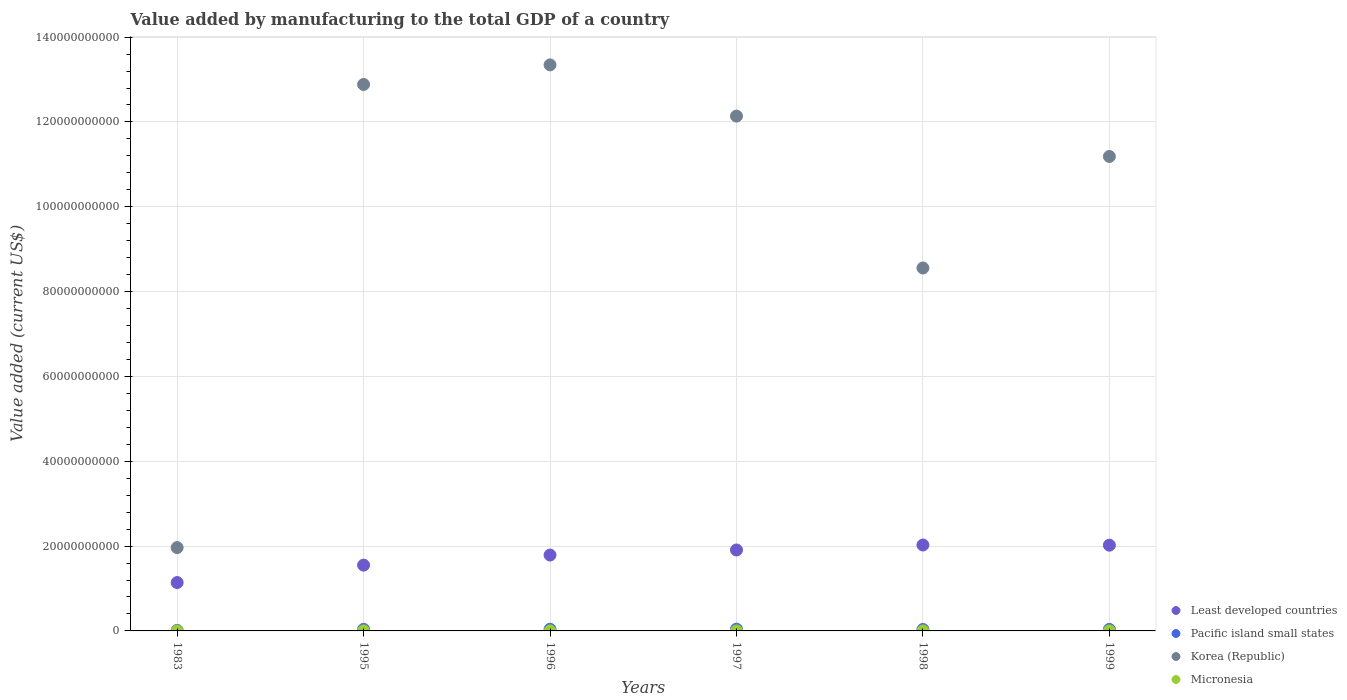How many different coloured dotlines are there?
Offer a terse response. 4. What is the value added by manufacturing to the total GDP in Least developed countries in 1996?
Give a very brief answer. 1.79e+1. Across all years, what is the maximum value added by manufacturing to the total GDP in Pacific island small states?
Your answer should be compact. 4.08e+08. Across all years, what is the minimum value added by manufacturing to the total GDP in Pacific island small states?
Offer a terse response. 1.26e+08. In which year was the value added by manufacturing to the total GDP in Pacific island small states minimum?
Keep it short and to the point. 1983. What is the total value added by manufacturing to the total GDP in Korea (Republic) in the graph?
Make the answer very short. 6.01e+11. What is the difference between the value added by manufacturing to the total GDP in Pacific island small states in 1983 and that in 1996?
Your answer should be very brief. -2.58e+08. What is the difference between the value added by manufacturing to the total GDP in Least developed countries in 1983 and the value added by manufacturing to the total GDP in Korea (Republic) in 1999?
Offer a terse response. -1.00e+11. What is the average value added by manufacturing to the total GDP in Korea (Republic) per year?
Offer a very short reply. 1.00e+11. In the year 1998, what is the difference between the value added by manufacturing to the total GDP in Micronesia and value added by manufacturing to the total GDP in Least developed countries?
Offer a very short reply. -2.03e+1. What is the ratio of the value added by manufacturing to the total GDP in Pacific island small states in 1996 to that in 1999?
Your response must be concise. 1.08. Is the value added by manufacturing to the total GDP in Korea (Republic) in 1996 less than that in 1999?
Make the answer very short. No. What is the difference between the highest and the second highest value added by manufacturing to the total GDP in Pacific island small states?
Your response must be concise. 2.43e+07. What is the difference between the highest and the lowest value added by manufacturing to the total GDP in Micronesia?
Offer a very short reply. 3.03e+06. In how many years, is the value added by manufacturing to the total GDP in Pacific island small states greater than the average value added by manufacturing to the total GDP in Pacific island small states taken over all years?
Provide a succinct answer. 5. Is the sum of the value added by manufacturing to the total GDP in Korea (Republic) in 1996 and 1998 greater than the maximum value added by manufacturing to the total GDP in Pacific island small states across all years?
Your answer should be very brief. Yes. Is it the case that in every year, the sum of the value added by manufacturing to the total GDP in Least developed countries and value added by manufacturing to the total GDP in Micronesia  is greater than the value added by manufacturing to the total GDP in Korea (Republic)?
Your response must be concise. No. How many dotlines are there?
Keep it short and to the point. 4. What is the difference between two consecutive major ticks on the Y-axis?
Your answer should be compact. 2.00e+1. Are the values on the major ticks of Y-axis written in scientific E-notation?
Your answer should be very brief. No. How many legend labels are there?
Provide a short and direct response. 4. How are the legend labels stacked?
Your answer should be compact. Vertical. What is the title of the graph?
Your answer should be compact. Value added by manufacturing to the total GDP of a country. Does "Bhutan" appear as one of the legend labels in the graph?
Offer a very short reply. No. What is the label or title of the X-axis?
Provide a short and direct response. Years. What is the label or title of the Y-axis?
Your answer should be compact. Value added (current US$). What is the Value added (current US$) of Least developed countries in 1983?
Offer a very short reply. 1.14e+1. What is the Value added (current US$) of Pacific island small states in 1983?
Offer a terse response. 1.26e+08. What is the Value added (current US$) in Korea (Republic) in 1983?
Offer a terse response. 1.96e+1. What is the Value added (current US$) of Least developed countries in 1995?
Provide a succinct answer. 1.55e+1. What is the Value added (current US$) in Pacific island small states in 1995?
Your answer should be very brief. 3.65e+08. What is the Value added (current US$) in Korea (Republic) in 1995?
Your answer should be compact. 1.29e+11. What is the Value added (current US$) of Micronesia in 1995?
Your answer should be compact. 3.14e+06. What is the Value added (current US$) in Least developed countries in 1996?
Provide a short and direct response. 1.79e+1. What is the Value added (current US$) of Pacific island small states in 1996?
Give a very brief answer. 3.83e+08. What is the Value added (current US$) of Korea (Republic) in 1996?
Your answer should be very brief. 1.33e+11. What is the Value added (current US$) in Micronesia in 1996?
Offer a terse response. 2.63e+06. What is the Value added (current US$) in Least developed countries in 1997?
Offer a terse response. 1.91e+1. What is the Value added (current US$) in Pacific island small states in 1997?
Provide a succinct answer. 4.08e+08. What is the Value added (current US$) in Korea (Republic) in 1997?
Offer a very short reply. 1.21e+11. What is the Value added (current US$) in Micronesia in 1997?
Give a very brief answer. 3.01e+06. What is the Value added (current US$) of Least developed countries in 1998?
Give a very brief answer. 2.03e+1. What is the Value added (current US$) in Pacific island small states in 1998?
Your answer should be compact. 3.37e+08. What is the Value added (current US$) of Korea (Republic) in 1998?
Offer a very short reply. 8.56e+1. What is the Value added (current US$) of Micronesia in 1998?
Keep it short and to the point. 3.43e+06. What is the Value added (current US$) in Least developed countries in 1999?
Keep it short and to the point. 2.02e+1. What is the Value added (current US$) of Pacific island small states in 1999?
Keep it short and to the point. 3.54e+08. What is the Value added (current US$) of Korea (Republic) in 1999?
Your response must be concise. 1.12e+11. What is the Value added (current US$) of Micronesia in 1999?
Provide a short and direct response. 3.29e+06. Across all years, what is the maximum Value added (current US$) in Least developed countries?
Offer a very short reply. 2.03e+1. Across all years, what is the maximum Value added (current US$) in Pacific island small states?
Make the answer very short. 4.08e+08. Across all years, what is the maximum Value added (current US$) of Korea (Republic)?
Make the answer very short. 1.33e+11. Across all years, what is the maximum Value added (current US$) in Micronesia?
Your response must be concise. 3.43e+06. Across all years, what is the minimum Value added (current US$) in Least developed countries?
Offer a terse response. 1.14e+1. Across all years, what is the minimum Value added (current US$) in Pacific island small states?
Ensure brevity in your answer.  1.26e+08. Across all years, what is the minimum Value added (current US$) in Korea (Republic)?
Your answer should be very brief. 1.96e+1. Across all years, what is the minimum Value added (current US$) in Micronesia?
Your response must be concise. 4.00e+05. What is the total Value added (current US$) in Least developed countries in the graph?
Your answer should be compact. 1.04e+11. What is the total Value added (current US$) of Pacific island small states in the graph?
Your response must be concise. 1.97e+09. What is the total Value added (current US$) of Korea (Republic) in the graph?
Make the answer very short. 6.01e+11. What is the total Value added (current US$) in Micronesia in the graph?
Your answer should be very brief. 1.59e+07. What is the difference between the Value added (current US$) in Least developed countries in 1983 and that in 1995?
Your response must be concise. -4.11e+09. What is the difference between the Value added (current US$) of Pacific island small states in 1983 and that in 1995?
Offer a very short reply. -2.40e+08. What is the difference between the Value added (current US$) of Korea (Republic) in 1983 and that in 1995?
Your answer should be very brief. -1.09e+11. What is the difference between the Value added (current US$) in Micronesia in 1983 and that in 1995?
Make the answer very short. -2.74e+06. What is the difference between the Value added (current US$) of Least developed countries in 1983 and that in 1996?
Your answer should be very brief. -6.49e+09. What is the difference between the Value added (current US$) in Pacific island small states in 1983 and that in 1996?
Ensure brevity in your answer.  -2.58e+08. What is the difference between the Value added (current US$) in Korea (Republic) in 1983 and that in 1996?
Make the answer very short. -1.14e+11. What is the difference between the Value added (current US$) in Micronesia in 1983 and that in 1996?
Offer a terse response. -2.23e+06. What is the difference between the Value added (current US$) of Least developed countries in 1983 and that in 1997?
Your answer should be compact. -7.68e+09. What is the difference between the Value added (current US$) of Pacific island small states in 1983 and that in 1997?
Offer a very short reply. -2.82e+08. What is the difference between the Value added (current US$) in Korea (Republic) in 1983 and that in 1997?
Your answer should be very brief. -1.02e+11. What is the difference between the Value added (current US$) in Micronesia in 1983 and that in 1997?
Offer a very short reply. -2.61e+06. What is the difference between the Value added (current US$) in Least developed countries in 1983 and that in 1998?
Provide a succinct answer. -8.85e+09. What is the difference between the Value added (current US$) in Pacific island small states in 1983 and that in 1998?
Your answer should be very brief. -2.11e+08. What is the difference between the Value added (current US$) in Korea (Republic) in 1983 and that in 1998?
Provide a succinct answer. -6.59e+1. What is the difference between the Value added (current US$) of Micronesia in 1983 and that in 1998?
Keep it short and to the point. -3.03e+06. What is the difference between the Value added (current US$) in Least developed countries in 1983 and that in 1999?
Offer a very short reply. -8.81e+09. What is the difference between the Value added (current US$) of Pacific island small states in 1983 and that in 1999?
Your answer should be compact. -2.28e+08. What is the difference between the Value added (current US$) in Korea (Republic) in 1983 and that in 1999?
Make the answer very short. -9.22e+1. What is the difference between the Value added (current US$) in Micronesia in 1983 and that in 1999?
Provide a succinct answer. -2.89e+06. What is the difference between the Value added (current US$) in Least developed countries in 1995 and that in 1996?
Make the answer very short. -2.38e+09. What is the difference between the Value added (current US$) of Pacific island small states in 1995 and that in 1996?
Keep it short and to the point. -1.80e+07. What is the difference between the Value added (current US$) in Korea (Republic) in 1995 and that in 1996?
Your answer should be compact. -4.61e+09. What is the difference between the Value added (current US$) in Micronesia in 1995 and that in 1996?
Provide a succinct answer. 5.06e+05. What is the difference between the Value added (current US$) in Least developed countries in 1995 and that in 1997?
Provide a succinct answer. -3.57e+09. What is the difference between the Value added (current US$) in Pacific island small states in 1995 and that in 1997?
Offer a very short reply. -4.23e+07. What is the difference between the Value added (current US$) in Korea (Republic) in 1995 and that in 1997?
Your answer should be compact. 7.46e+09. What is the difference between the Value added (current US$) in Micronesia in 1995 and that in 1997?
Your answer should be compact. 1.27e+05. What is the difference between the Value added (current US$) of Least developed countries in 1995 and that in 1998?
Offer a very short reply. -4.74e+09. What is the difference between the Value added (current US$) of Pacific island small states in 1995 and that in 1998?
Make the answer very short. 2.82e+07. What is the difference between the Value added (current US$) in Korea (Republic) in 1995 and that in 1998?
Your response must be concise. 4.33e+1. What is the difference between the Value added (current US$) in Micronesia in 1995 and that in 1998?
Provide a succinct answer. -2.92e+05. What is the difference between the Value added (current US$) of Least developed countries in 1995 and that in 1999?
Give a very brief answer. -4.70e+09. What is the difference between the Value added (current US$) in Pacific island small states in 1995 and that in 1999?
Offer a terse response. 1.17e+07. What is the difference between the Value added (current US$) of Korea (Republic) in 1995 and that in 1999?
Ensure brevity in your answer.  1.70e+1. What is the difference between the Value added (current US$) in Micronesia in 1995 and that in 1999?
Your answer should be very brief. -1.56e+05. What is the difference between the Value added (current US$) of Least developed countries in 1996 and that in 1997?
Offer a very short reply. -1.19e+09. What is the difference between the Value added (current US$) of Pacific island small states in 1996 and that in 1997?
Offer a terse response. -2.43e+07. What is the difference between the Value added (current US$) in Korea (Republic) in 1996 and that in 1997?
Offer a very short reply. 1.21e+1. What is the difference between the Value added (current US$) of Micronesia in 1996 and that in 1997?
Your answer should be very brief. -3.79e+05. What is the difference between the Value added (current US$) of Least developed countries in 1996 and that in 1998?
Offer a very short reply. -2.36e+09. What is the difference between the Value added (current US$) in Pacific island small states in 1996 and that in 1998?
Give a very brief answer. 4.62e+07. What is the difference between the Value added (current US$) in Korea (Republic) in 1996 and that in 1998?
Offer a terse response. 4.79e+1. What is the difference between the Value added (current US$) of Micronesia in 1996 and that in 1998?
Offer a very short reply. -7.98e+05. What is the difference between the Value added (current US$) in Least developed countries in 1996 and that in 1999?
Provide a short and direct response. -2.32e+09. What is the difference between the Value added (current US$) of Pacific island small states in 1996 and that in 1999?
Your answer should be very brief. 2.97e+07. What is the difference between the Value added (current US$) in Korea (Republic) in 1996 and that in 1999?
Your answer should be very brief. 2.16e+1. What is the difference between the Value added (current US$) in Micronesia in 1996 and that in 1999?
Offer a very short reply. -6.62e+05. What is the difference between the Value added (current US$) in Least developed countries in 1997 and that in 1998?
Make the answer very short. -1.17e+09. What is the difference between the Value added (current US$) in Pacific island small states in 1997 and that in 1998?
Your answer should be compact. 7.04e+07. What is the difference between the Value added (current US$) of Korea (Republic) in 1997 and that in 1998?
Offer a terse response. 3.58e+1. What is the difference between the Value added (current US$) in Micronesia in 1997 and that in 1998?
Make the answer very short. -4.19e+05. What is the difference between the Value added (current US$) in Least developed countries in 1997 and that in 1999?
Your answer should be very brief. -1.13e+09. What is the difference between the Value added (current US$) of Pacific island small states in 1997 and that in 1999?
Offer a terse response. 5.40e+07. What is the difference between the Value added (current US$) of Korea (Republic) in 1997 and that in 1999?
Provide a short and direct response. 9.52e+09. What is the difference between the Value added (current US$) in Micronesia in 1997 and that in 1999?
Your response must be concise. -2.83e+05. What is the difference between the Value added (current US$) of Least developed countries in 1998 and that in 1999?
Offer a very short reply. 4.31e+07. What is the difference between the Value added (current US$) in Pacific island small states in 1998 and that in 1999?
Keep it short and to the point. -1.65e+07. What is the difference between the Value added (current US$) in Korea (Republic) in 1998 and that in 1999?
Give a very brief answer. -2.63e+1. What is the difference between the Value added (current US$) in Micronesia in 1998 and that in 1999?
Give a very brief answer. 1.36e+05. What is the difference between the Value added (current US$) in Least developed countries in 1983 and the Value added (current US$) in Pacific island small states in 1995?
Your answer should be very brief. 1.10e+1. What is the difference between the Value added (current US$) of Least developed countries in 1983 and the Value added (current US$) of Korea (Republic) in 1995?
Ensure brevity in your answer.  -1.17e+11. What is the difference between the Value added (current US$) in Least developed countries in 1983 and the Value added (current US$) in Micronesia in 1995?
Keep it short and to the point. 1.14e+1. What is the difference between the Value added (current US$) of Pacific island small states in 1983 and the Value added (current US$) of Korea (Republic) in 1995?
Make the answer very short. -1.29e+11. What is the difference between the Value added (current US$) of Pacific island small states in 1983 and the Value added (current US$) of Micronesia in 1995?
Your answer should be compact. 1.22e+08. What is the difference between the Value added (current US$) of Korea (Republic) in 1983 and the Value added (current US$) of Micronesia in 1995?
Your answer should be compact. 1.96e+1. What is the difference between the Value added (current US$) in Least developed countries in 1983 and the Value added (current US$) in Pacific island small states in 1996?
Your answer should be compact. 1.10e+1. What is the difference between the Value added (current US$) of Least developed countries in 1983 and the Value added (current US$) of Korea (Republic) in 1996?
Your answer should be very brief. -1.22e+11. What is the difference between the Value added (current US$) in Least developed countries in 1983 and the Value added (current US$) in Micronesia in 1996?
Offer a terse response. 1.14e+1. What is the difference between the Value added (current US$) of Pacific island small states in 1983 and the Value added (current US$) of Korea (Republic) in 1996?
Provide a succinct answer. -1.33e+11. What is the difference between the Value added (current US$) in Pacific island small states in 1983 and the Value added (current US$) in Micronesia in 1996?
Offer a terse response. 1.23e+08. What is the difference between the Value added (current US$) in Korea (Republic) in 1983 and the Value added (current US$) in Micronesia in 1996?
Make the answer very short. 1.96e+1. What is the difference between the Value added (current US$) in Least developed countries in 1983 and the Value added (current US$) in Pacific island small states in 1997?
Your answer should be very brief. 1.10e+1. What is the difference between the Value added (current US$) in Least developed countries in 1983 and the Value added (current US$) in Korea (Republic) in 1997?
Make the answer very short. -1.10e+11. What is the difference between the Value added (current US$) of Least developed countries in 1983 and the Value added (current US$) of Micronesia in 1997?
Offer a terse response. 1.14e+1. What is the difference between the Value added (current US$) in Pacific island small states in 1983 and the Value added (current US$) in Korea (Republic) in 1997?
Provide a short and direct response. -1.21e+11. What is the difference between the Value added (current US$) of Pacific island small states in 1983 and the Value added (current US$) of Micronesia in 1997?
Your answer should be compact. 1.23e+08. What is the difference between the Value added (current US$) in Korea (Republic) in 1983 and the Value added (current US$) in Micronesia in 1997?
Your answer should be very brief. 1.96e+1. What is the difference between the Value added (current US$) of Least developed countries in 1983 and the Value added (current US$) of Pacific island small states in 1998?
Provide a short and direct response. 1.11e+1. What is the difference between the Value added (current US$) of Least developed countries in 1983 and the Value added (current US$) of Korea (Republic) in 1998?
Offer a very short reply. -7.42e+1. What is the difference between the Value added (current US$) of Least developed countries in 1983 and the Value added (current US$) of Micronesia in 1998?
Ensure brevity in your answer.  1.14e+1. What is the difference between the Value added (current US$) of Pacific island small states in 1983 and the Value added (current US$) of Korea (Republic) in 1998?
Provide a short and direct response. -8.54e+1. What is the difference between the Value added (current US$) in Pacific island small states in 1983 and the Value added (current US$) in Micronesia in 1998?
Provide a succinct answer. 1.22e+08. What is the difference between the Value added (current US$) of Korea (Republic) in 1983 and the Value added (current US$) of Micronesia in 1998?
Give a very brief answer. 1.96e+1. What is the difference between the Value added (current US$) of Least developed countries in 1983 and the Value added (current US$) of Pacific island small states in 1999?
Give a very brief answer. 1.11e+1. What is the difference between the Value added (current US$) in Least developed countries in 1983 and the Value added (current US$) in Korea (Republic) in 1999?
Provide a succinct answer. -1.00e+11. What is the difference between the Value added (current US$) of Least developed countries in 1983 and the Value added (current US$) of Micronesia in 1999?
Make the answer very short. 1.14e+1. What is the difference between the Value added (current US$) in Pacific island small states in 1983 and the Value added (current US$) in Korea (Republic) in 1999?
Make the answer very short. -1.12e+11. What is the difference between the Value added (current US$) of Pacific island small states in 1983 and the Value added (current US$) of Micronesia in 1999?
Your answer should be very brief. 1.22e+08. What is the difference between the Value added (current US$) in Korea (Republic) in 1983 and the Value added (current US$) in Micronesia in 1999?
Offer a very short reply. 1.96e+1. What is the difference between the Value added (current US$) of Least developed countries in 1995 and the Value added (current US$) of Pacific island small states in 1996?
Provide a short and direct response. 1.51e+1. What is the difference between the Value added (current US$) in Least developed countries in 1995 and the Value added (current US$) in Korea (Republic) in 1996?
Provide a succinct answer. -1.18e+11. What is the difference between the Value added (current US$) of Least developed countries in 1995 and the Value added (current US$) of Micronesia in 1996?
Your response must be concise. 1.55e+1. What is the difference between the Value added (current US$) in Pacific island small states in 1995 and the Value added (current US$) in Korea (Republic) in 1996?
Provide a succinct answer. -1.33e+11. What is the difference between the Value added (current US$) in Pacific island small states in 1995 and the Value added (current US$) in Micronesia in 1996?
Your answer should be very brief. 3.63e+08. What is the difference between the Value added (current US$) of Korea (Republic) in 1995 and the Value added (current US$) of Micronesia in 1996?
Provide a short and direct response. 1.29e+11. What is the difference between the Value added (current US$) in Least developed countries in 1995 and the Value added (current US$) in Pacific island small states in 1997?
Give a very brief answer. 1.51e+1. What is the difference between the Value added (current US$) of Least developed countries in 1995 and the Value added (current US$) of Korea (Republic) in 1997?
Your answer should be very brief. -1.06e+11. What is the difference between the Value added (current US$) of Least developed countries in 1995 and the Value added (current US$) of Micronesia in 1997?
Offer a terse response. 1.55e+1. What is the difference between the Value added (current US$) of Pacific island small states in 1995 and the Value added (current US$) of Korea (Republic) in 1997?
Give a very brief answer. -1.21e+11. What is the difference between the Value added (current US$) in Pacific island small states in 1995 and the Value added (current US$) in Micronesia in 1997?
Your answer should be compact. 3.62e+08. What is the difference between the Value added (current US$) in Korea (Republic) in 1995 and the Value added (current US$) in Micronesia in 1997?
Offer a terse response. 1.29e+11. What is the difference between the Value added (current US$) in Least developed countries in 1995 and the Value added (current US$) in Pacific island small states in 1998?
Your answer should be very brief. 1.52e+1. What is the difference between the Value added (current US$) in Least developed countries in 1995 and the Value added (current US$) in Korea (Republic) in 1998?
Keep it short and to the point. -7.01e+1. What is the difference between the Value added (current US$) of Least developed countries in 1995 and the Value added (current US$) of Micronesia in 1998?
Give a very brief answer. 1.55e+1. What is the difference between the Value added (current US$) of Pacific island small states in 1995 and the Value added (current US$) of Korea (Republic) in 1998?
Your response must be concise. -8.52e+1. What is the difference between the Value added (current US$) in Pacific island small states in 1995 and the Value added (current US$) in Micronesia in 1998?
Ensure brevity in your answer.  3.62e+08. What is the difference between the Value added (current US$) in Korea (Republic) in 1995 and the Value added (current US$) in Micronesia in 1998?
Keep it short and to the point. 1.29e+11. What is the difference between the Value added (current US$) of Least developed countries in 1995 and the Value added (current US$) of Pacific island small states in 1999?
Keep it short and to the point. 1.52e+1. What is the difference between the Value added (current US$) of Least developed countries in 1995 and the Value added (current US$) of Korea (Republic) in 1999?
Make the answer very short. -9.63e+1. What is the difference between the Value added (current US$) of Least developed countries in 1995 and the Value added (current US$) of Micronesia in 1999?
Your response must be concise. 1.55e+1. What is the difference between the Value added (current US$) of Pacific island small states in 1995 and the Value added (current US$) of Korea (Republic) in 1999?
Provide a short and direct response. -1.11e+11. What is the difference between the Value added (current US$) of Pacific island small states in 1995 and the Value added (current US$) of Micronesia in 1999?
Provide a short and direct response. 3.62e+08. What is the difference between the Value added (current US$) in Korea (Republic) in 1995 and the Value added (current US$) in Micronesia in 1999?
Give a very brief answer. 1.29e+11. What is the difference between the Value added (current US$) in Least developed countries in 1996 and the Value added (current US$) in Pacific island small states in 1997?
Provide a short and direct response. 1.75e+1. What is the difference between the Value added (current US$) in Least developed countries in 1996 and the Value added (current US$) in Korea (Republic) in 1997?
Offer a terse response. -1.03e+11. What is the difference between the Value added (current US$) in Least developed countries in 1996 and the Value added (current US$) in Micronesia in 1997?
Keep it short and to the point. 1.79e+1. What is the difference between the Value added (current US$) in Pacific island small states in 1996 and the Value added (current US$) in Korea (Republic) in 1997?
Make the answer very short. -1.21e+11. What is the difference between the Value added (current US$) of Pacific island small states in 1996 and the Value added (current US$) of Micronesia in 1997?
Your response must be concise. 3.80e+08. What is the difference between the Value added (current US$) in Korea (Republic) in 1996 and the Value added (current US$) in Micronesia in 1997?
Make the answer very short. 1.33e+11. What is the difference between the Value added (current US$) of Least developed countries in 1996 and the Value added (current US$) of Pacific island small states in 1998?
Provide a succinct answer. 1.76e+1. What is the difference between the Value added (current US$) in Least developed countries in 1996 and the Value added (current US$) in Korea (Republic) in 1998?
Offer a very short reply. -6.77e+1. What is the difference between the Value added (current US$) in Least developed countries in 1996 and the Value added (current US$) in Micronesia in 1998?
Your response must be concise. 1.79e+1. What is the difference between the Value added (current US$) of Pacific island small states in 1996 and the Value added (current US$) of Korea (Republic) in 1998?
Offer a very short reply. -8.52e+1. What is the difference between the Value added (current US$) of Pacific island small states in 1996 and the Value added (current US$) of Micronesia in 1998?
Offer a very short reply. 3.80e+08. What is the difference between the Value added (current US$) of Korea (Republic) in 1996 and the Value added (current US$) of Micronesia in 1998?
Provide a succinct answer. 1.33e+11. What is the difference between the Value added (current US$) in Least developed countries in 1996 and the Value added (current US$) in Pacific island small states in 1999?
Offer a terse response. 1.75e+1. What is the difference between the Value added (current US$) in Least developed countries in 1996 and the Value added (current US$) in Korea (Republic) in 1999?
Provide a succinct answer. -9.40e+1. What is the difference between the Value added (current US$) in Least developed countries in 1996 and the Value added (current US$) in Micronesia in 1999?
Your response must be concise. 1.79e+1. What is the difference between the Value added (current US$) of Pacific island small states in 1996 and the Value added (current US$) of Korea (Republic) in 1999?
Your answer should be very brief. -1.11e+11. What is the difference between the Value added (current US$) of Pacific island small states in 1996 and the Value added (current US$) of Micronesia in 1999?
Offer a terse response. 3.80e+08. What is the difference between the Value added (current US$) of Korea (Republic) in 1996 and the Value added (current US$) of Micronesia in 1999?
Offer a very short reply. 1.33e+11. What is the difference between the Value added (current US$) of Least developed countries in 1997 and the Value added (current US$) of Pacific island small states in 1998?
Your response must be concise. 1.87e+1. What is the difference between the Value added (current US$) in Least developed countries in 1997 and the Value added (current US$) in Korea (Republic) in 1998?
Provide a short and direct response. -6.65e+1. What is the difference between the Value added (current US$) of Least developed countries in 1997 and the Value added (current US$) of Micronesia in 1998?
Your answer should be compact. 1.91e+1. What is the difference between the Value added (current US$) of Pacific island small states in 1997 and the Value added (current US$) of Korea (Republic) in 1998?
Offer a terse response. -8.52e+1. What is the difference between the Value added (current US$) in Pacific island small states in 1997 and the Value added (current US$) in Micronesia in 1998?
Make the answer very short. 4.04e+08. What is the difference between the Value added (current US$) in Korea (Republic) in 1997 and the Value added (current US$) in Micronesia in 1998?
Offer a very short reply. 1.21e+11. What is the difference between the Value added (current US$) in Least developed countries in 1997 and the Value added (current US$) in Pacific island small states in 1999?
Offer a terse response. 1.87e+1. What is the difference between the Value added (current US$) in Least developed countries in 1997 and the Value added (current US$) in Korea (Republic) in 1999?
Offer a terse response. -9.28e+1. What is the difference between the Value added (current US$) of Least developed countries in 1997 and the Value added (current US$) of Micronesia in 1999?
Make the answer very short. 1.91e+1. What is the difference between the Value added (current US$) of Pacific island small states in 1997 and the Value added (current US$) of Korea (Republic) in 1999?
Give a very brief answer. -1.11e+11. What is the difference between the Value added (current US$) in Pacific island small states in 1997 and the Value added (current US$) in Micronesia in 1999?
Your answer should be very brief. 4.04e+08. What is the difference between the Value added (current US$) in Korea (Republic) in 1997 and the Value added (current US$) in Micronesia in 1999?
Offer a terse response. 1.21e+11. What is the difference between the Value added (current US$) in Least developed countries in 1998 and the Value added (current US$) in Pacific island small states in 1999?
Offer a very short reply. 1.99e+1. What is the difference between the Value added (current US$) in Least developed countries in 1998 and the Value added (current US$) in Korea (Republic) in 1999?
Offer a very short reply. -9.16e+1. What is the difference between the Value added (current US$) of Least developed countries in 1998 and the Value added (current US$) of Micronesia in 1999?
Give a very brief answer. 2.03e+1. What is the difference between the Value added (current US$) in Pacific island small states in 1998 and the Value added (current US$) in Korea (Republic) in 1999?
Your answer should be compact. -1.12e+11. What is the difference between the Value added (current US$) in Pacific island small states in 1998 and the Value added (current US$) in Micronesia in 1999?
Offer a very short reply. 3.34e+08. What is the difference between the Value added (current US$) of Korea (Republic) in 1998 and the Value added (current US$) of Micronesia in 1999?
Provide a short and direct response. 8.56e+1. What is the average Value added (current US$) in Least developed countries per year?
Your response must be concise. 1.74e+1. What is the average Value added (current US$) in Pacific island small states per year?
Make the answer very short. 3.29e+08. What is the average Value added (current US$) of Korea (Republic) per year?
Make the answer very short. 1.00e+11. What is the average Value added (current US$) in Micronesia per year?
Give a very brief answer. 2.65e+06. In the year 1983, what is the difference between the Value added (current US$) of Least developed countries and Value added (current US$) of Pacific island small states?
Provide a succinct answer. 1.13e+1. In the year 1983, what is the difference between the Value added (current US$) in Least developed countries and Value added (current US$) in Korea (Republic)?
Ensure brevity in your answer.  -8.24e+09. In the year 1983, what is the difference between the Value added (current US$) in Least developed countries and Value added (current US$) in Micronesia?
Give a very brief answer. 1.14e+1. In the year 1983, what is the difference between the Value added (current US$) of Pacific island small states and Value added (current US$) of Korea (Republic)?
Offer a terse response. -1.95e+1. In the year 1983, what is the difference between the Value added (current US$) in Pacific island small states and Value added (current US$) in Micronesia?
Keep it short and to the point. 1.25e+08. In the year 1983, what is the difference between the Value added (current US$) of Korea (Republic) and Value added (current US$) of Micronesia?
Your answer should be very brief. 1.96e+1. In the year 1995, what is the difference between the Value added (current US$) in Least developed countries and Value added (current US$) in Pacific island small states?
Give a very brief answer. 1.51e+1. In the year 1995, what is the difference between the Value added (current US$) of Least developed countries and Value added (current US$) of Korea (Republic)?
Offer a very short reply. -1.13e+11. In the year 1995, what is the difference between the Value added (current US$) in Least developed countries and Value added (current US$) in Micronesia?
Offer a very short reply. 1.55e+1. In the year 1995, what is the difference between the Value added (current US$) in Pacific island small states and Value added (current US$) in Korea (Republic)?
Offer a terse response. -1.28e+11. In the year 1995, what is the difference between the Value added (current US$) of Pacific island small states and Value added (current US$) of Micronesia?
Offer a terse response. 3.62e+08. In the year 1995, what is the difference between the Value added (current US$) in Korea (Republic) and Value added (current US$) in Micronesia?
Make the answer very short. 1.29e+11. In the year 1996, what is the difference between the Value added (current US$) in Least developed countries and Value added (current US$) in Pacific island small states?
Your answer should be very brief. 1.75e+1. In the year 1996, what is the difference between the Value added (current US$) of Least developed countries and Value added (current US$) of Korea (Republic)?
Give a very brief answer. -1.16e+11. In the year 1996, what is the difference between the Value added (current US$) in Least developed countries and Value added (current US$) in Micronesia?
Ensure brevity in your answer.  1.79e+1. In the year 1996, what is the difference between the Value added (current US$) of Pacific island small states and Value added (current US$) of Korea (Republic)?
Your response must be concise. -1.33e+11. In the year 1996, what is the difference between the Value added (current US$) in Pacific island small states and Value added (current US$) in Micronesia?
Your response must be concise. 3.81e+08. In the year 1996, what is the difference between the Value added (current US$) in Korea (Republic) and Value added (current US$) in Micronesia?
Provide a short and direct response. 1.33e+11. In the year 1997, what is the difference between the Value added (current US$) in Least developed countries and Value added (current US$) in Pacific island small states?
Provide a succinct answer. 1.87e+1. In the year 1997, what is the difference between the Value added (current US$) in Least developed countries and Value added (current US$) in Korea (Republic)?
Your response must be concise. -1.02e+11. In the year 1997, what is the difference between the Value added (current US$) of Least developed countries and Value added (current US$) of Micronesia?
Give a very brief answer. 1.91e+1. In the year 1997, what is the difference between the Value added (current US$) in Pacific island small states and Value added (current US$) in Korea (Republic)?
Your response must be concise. -1.21e+11. In the year 1997, what is the difference between the Value added (current US$) in Pacific island small states and Value added (current US$) in Micronesia?
Make the answer very short. 4.05e+08. In the year 1997, what is the difference between the Value added (current US$) of Korea (Republic) and Value added (current US$) of Micronesia?
Ensure brevity in your answer.  1.21e+11. In the year 1998, what is the difference between the Value added (current US$) in Least developed countries and Value added (current US$) in Pacific island small states?
Provide a short and direct response. 1.99e+1. In the year 1998, what is the difference between the Value added (current US$) in Least developed countries and Value added (current US$) in Korea (Republic)?
Give a very brief answer. -6.53e+1. In the year 1998, what is the difference between the Value added (current US$) in Least developed countries and Value added (current US$) in Micronesia?
Keep it short and to the point. 2.03e+1. In the year 1998, what is the difference between the Value added (current US$) of Pacific island small states and Value added (current US$) of Korea (Republic)?
Give a very brief answer. -8.52e+1. In the year 1998, what is the difference between the Value added (current US$) in Pacific island small states and Value added (current US$) in Micronesia?
Your answer should be compact. 3.34e+08. In the year 1998, what is the difference between the Value added (current US$) in Korea (Republic) and Value added (current US$) in Micronesia?
Offer a very short reply. 8.56e+1. In the year 1999, what is the difference between the Value added (current US$) in Least developed countries and Value added (current US$) in Pacific island small states?
Ensure brevity in your answer.  1.99e+1. In the year 1999, what is the difference between the Value added (current US$) in Least developed countries and Value added (current US$) in Korea (Republic)?
Your answer should be very brief. -9.16e+1. In the year 1999, what is the difference between the Value added (current US$) of Least developed countries and Value added (current US$) of Micronesia?
Make the answer very short. 2.02e+1. In the year 1999, what is the difference between the Value added (current US$) of Pacific island small states and Value added (current US$) of Korea (Republic)?
Offer a terse response. -1.12e+11. In the year 1999, what is the difference between the Value added (current US$) in Pacific island small states and Value added (current US$) in Micronesia?
Give a very brief answer. 3.50e+08. In the year 1999, what is the difference between the Value added (current US$) of Korea (Republic) and Value added (current US$) of Micronesia?
Give a very brief answer. 1.12e+11. What is the ratio of the Value added (current US$) in Least developed countries in 1983 to that in 1995?
Give a very brief answer. 0.74. What is the ratio of the Value added (current US$) of Pacific island small states in 1983 to that in 1995?
Offer a very short reply. 0.34. What is the ratio of the Value added (current US$) in Korea (Republic) in 1983 to that in 1995?
Give a very brief answer. 0.15. What is the ratio of the Value added (current US$) in Micronesia in 1983 to that in 1995?
Your response must be concise. 0.13. What is the ratio of the Value added (current US$) of Least developed countries in 1983 to that in 1996?
Your response must be concise. 0.64. What is the ratio of the Value added (current US$) of Pacific island small states in 1983 to that in 1996?
Your answer should be very brief. 0.33. What is the ratio of the Value added (current US$) of Korea (Republic) in 1983 to that in 1996?
Your answer should be compact. 0.15. What is the ratio of the Value added (current US$) of Micronesia in 1983 to that in 1996?
Give a very brief answer. 0.15. What is the ratio of the Value added (current US$) in Least developed countries in 1983 to that in 1997?
Give a very brief answer. 0.6. What is the ratio of the Value added (current US$) in Pacific island small states in 1983 to that in 1997?
Offer a very short reply. 0.31. What is the ratio of the Value added (current US$) of Korea (Republic) in 1983 to that in 1997?
Give a very brief answer. 0.16. What is the ratio of the Value added (current US$) of Micronesia in 1983 to that in 1997?
Your response must be concise. 0.13. What is the ratio of the Value added (current US$) in Least developed countries in 1983 to that in 1998?
Keep it short and to the point. 0.56. What is the ratio of the Value added (current US$) of Pacific island small states in 1983 to that in 1998?
Your answer should be very brief. 0.37. What is the ratio of the Value added (current US$) of Korea (Republic) in 1983 to that in 1998?
Provide a short and direct response. 0.23. What is the ratio of the Value added (current US$) in Micronesia in 1983 to that in 1998?
Your answer should be very brief. 0.12. What is the ratio of the Value added (current US$) in Least developed countries in 1983 to that in 1999?
Your response must be concise. 0.56. What is the ratio of the Value added (current US$) in Pacific island small states in 1983 to that in 1999?
Provide a short and direct response. 0.36. What is the ratio of the Value added (current US$) of Korea (Republic) in 1983 to that in 1999?
Provide a short and direct response. 0.18. What is the ratio of the Value added (current US$) of Micronesia in 1983 to that in 1999?
Offer a very short reply. 0.12. What is the ratio of the Value added (current US$) of Least developed countries in 1995 to that in 1996?
Make the answer very short. 0.87. What is the ratio of the Value added (current US$) of Pacific island small states in 1995 to that in 1996?
Offer a very short reply. 0.95. What is the ratio of the Value added (current US$) of Korea (Republic) in 1995 to that in 1996?
Your answer should be compact. 0.97. What is the ratio of the Value added (current US$) of Micronesia in 1995 to that in 1996?
Your answer should be very brief. 1.19. What is the ratio of the Value added (current US$) in Least developed countries in 1995 to that in 1997?
Your response must be concise. 0.81. What is the ratio of the Value added (current US$) of Pacific island small states in 1995 to that in 1997?
Offer a terse response. 0.9. What is the ratio of the Value added (current US$) of Korea (Republic) in 1995 to that in 1997?
Ensure brevity in your answer.  1.06. What is the ratio of the Value added (current US$) in Micronesia in 1995 to that in 1997?
Offer a terse response. 1.04. What is the ratio of the Value added (current US$) in Least developed countries in 1995 to that in 1998?
Your answer should be compact. 0.77. What is the ratio of the Value added (current US$) in Pacific island small states in 1995 to that in 1998?
Your answer should be very brief. 1.08. What is the ratio of the Value added (current US$) of Korea (Republic) in 1995 to that in 1998?
Give a very brief answer. 1.51. What is the ratio of the Value added (current US$) in Micronesia in 1995 to that in 1998?
Ensure brevity in your answer.  0.92. What is the ratio of the Value added (current US$) in Least developed countries in 1995 to that in 1999?
Ensure brevity in your answer.  0.77. What is the ratio of the Value added (current US$) in Pacific island small states in 1995 to that in 1999?
Make the answer very short. 1.03. What is the ratio of the Value added (current US$) in Korea (Republic) in 1995 to that in 1999?
Give a very brief answer. 1.15. What is the ratio of the Value added (current US$) of Micronesia in 1995 to that in 1999?
Provide a short and direct response. 0.95. What is the ratio of the Value added (current US$) in Pacific island small states in 1996 to that in 1997?
Offer a terse response. 0.94. What is the ratio of the Value added (current US$) of Korea (Republic) in 1996 to that in 1997?
Provide a short and direct response. 1.1. What is the ratio of the Value added (current US$) in Micronesia in 1996 to that in 1997?
Your answer should be very brief. 0.87. What is the ratio of the Value added (current US$) of Least developed countries in 1996 to that in 1998?
Your answer should be compact. 0.88. What is the ratio of the Value added (current US$) of Pacific island small states in 1996 to that in 1998?
Provide a succinct answer. 1.14. What is the ratio of the Value added (current US$) in Korea (Republic) in 1996 to that in 1998?
Offer a very short reply. 1.56. What is the ratio of the Value added (current US$) in Micronesia in 1996 to that in 1998?
Give a very brief answer. 0.77. What is the ratio of the Value added (current US$) of Least developed countries in 1996 to that in 1999?
Give a very brief answer. 0.89. What is the ratio of the Value added (current US$) in Pacific island small states in 1996 to that in 1999?
Your answer should be very brief. 1.08. What is the ratio of the Value added (current US$) of Korea (Republic) in 1996 to that in 1999?
Your answer should be compact. 1.19. What is the ratio of the Value added (current US$) in Micronesia in 1996 to that in 1999?
Your response must be concise. 0.8. What is the ratio of the Value added (current US$) of Least developed countries in 1997 to that in 1998?
Your response must be concise. 0.94. What is the ratio of the Value added (current US$) in Pacific island small states in 1997 to that in 1998?
Your answer should be very brief. 1.21. What is the ratio of the Value added (current US$) of Korea (Republic) in 1997 to that in 1998?
Your response must be concise. 1.42. What is the ratio of the Value added (current US$) in Micronesia in 1997 to that in 1998?
Provide a short and direct response. 0.88. What is the ratio of the Value added (current US$) in Least developed countries in 1997 to that in 1999?
Provide a succinct answer. 0.94. What is the ratio of the Value added (current US$) in Pacific island small states in 1997 to that in 1999?
Provide a short and direct response. 1.15. What is the ratio of the Value added (current US$) in Korea (Republic) in 1997 to that in 1999?
Make the answer very short. 1.09. What is the ratio of the Value added (current US$) of Micronesia in 1997 to that in 1999?
Keep it short and to the point. 0.91. What is the ratio of the Value added (current US$) of Pacific island small states in 1998 to that in 1999?
Provide a succinct answer. 0.95. What is the ratio of the Value added (current US$) of Korea (Republic) in 1998 to that in 1999?
Provide a short and direct response. 0.77. What is the ratio of the Value added (current US$) in Micronesia in 1998 to that in 1999?
Ensure brevity in your answer.  1.04. What is the difference between the highest and the second highest Value added (current US$) of Least developed countries?
Provide a short and direct response. 4.31e+07. What is the difference between the highest and the second highest Value added (current US$) in Pacific island small states?
Your response must be concise. 2.43e+07. What is the difference between the highest and the second highest Value added (current US$) of Korea (Republic)?
Your answer should be very brief. 4.61e+09. What is the difference between the highest and the second highest Value added (current US$) of Micronesia?
Keep it short and to the point. 1.36e+05. What is the difference between the highest and the lowest Value added (current US$) of Least developed countries?
Make the answer very short. 8.85e+09. What is the difference between the highest and the lowest Value added (current US$) of Pacific island small states?
Provide a short and direct response. 2.82e+08. What is the difference between the highest and the lowest Value added (current US$) of Korea (Republic)?
Make the answer very short. 1.14e+11. What is the difference between the highest and the lowest Value added (current US$) in Micronesia?
Your answer should be very brief. 3.03e+06. 